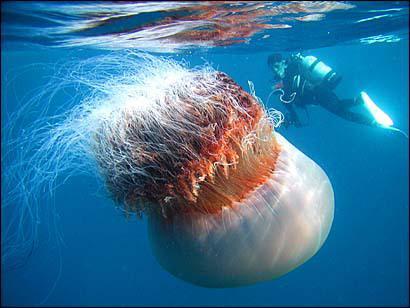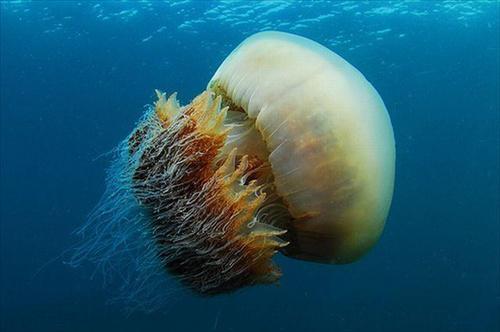The first image is the image on the left, the second image is the image on the right. Considering the images on both sides, is "There is a scuba diver with an airtank swimming with a jellyfish." valid? Answer yes or no. Yes. 